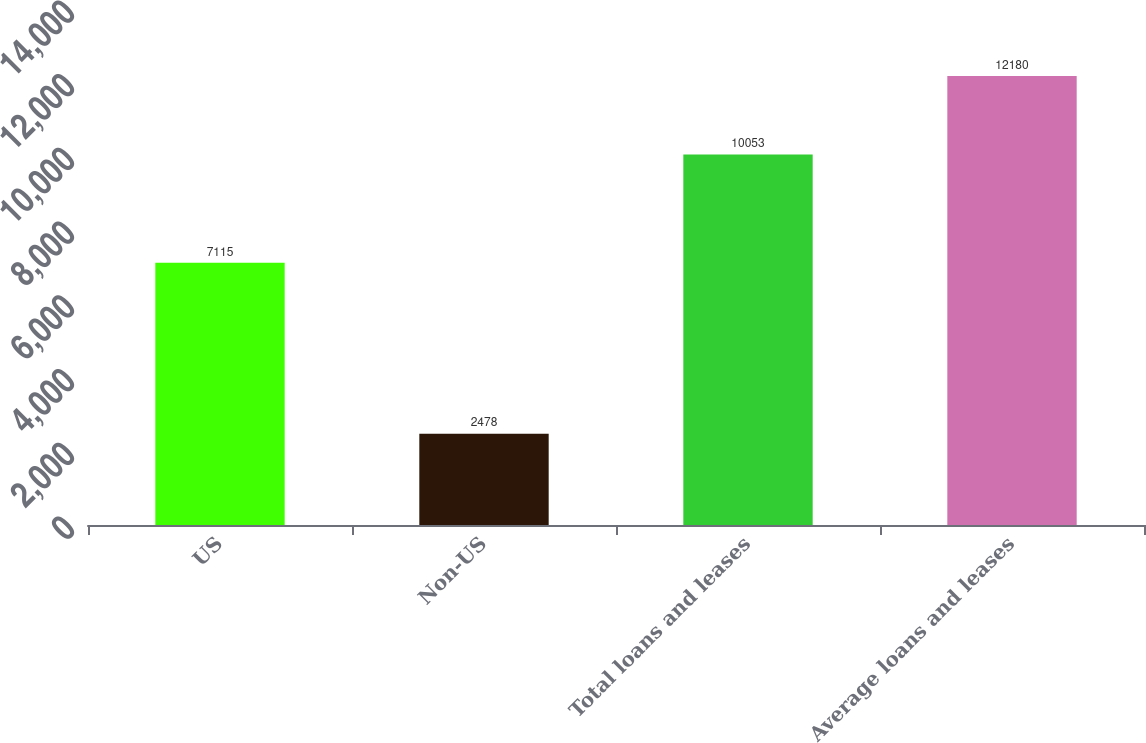Convert chart. <chart><loc_0><loc_0><loc_500><loc_500><bar_chart><fcel>US<fcel>Non-US<fcel>Total loans and leases<fcel>Average loans and leases<nl><fcel>7115<fcel>2478<fcel>10053<fcel>12180<nl></chart> 